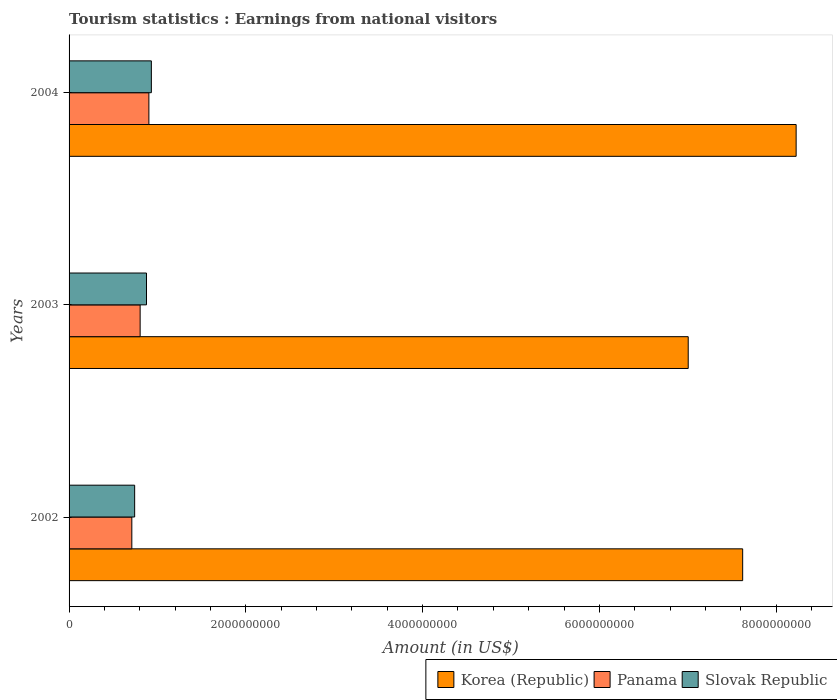How many different coloured bars are there?
Ensure brevity in your answer.  3. Are the number of bars per tick equal to the number of legend labels?
Give a very brief answer. Yes. How many bars are there on the 3rd tick from the top?
Your answer should be compact. 3. How many bars are there on the 2nd tick from the bottom?
Your answer should be compact. 3. In how many cases, is the number of bars for a given year not equal to the number of legend labels?
Your answer should be compact. 0. What is the earnings from national visitors in Slovak Republic in 2003?
Give a very brief answer. 8.76e+08. Across all years, what is the maximum earnings from national visitors in Panama?
Offer a very short reply. 9.03e+08. Across all years, what is the minimum earnings from national visitors in Panama?
Provide a succinct answer. 7.10e+08. In which year was the earnings from national visitors in Slovak Republic maximum?
Ensure brevity in your answer.  2004. In which year was the earnings from national visitors in Slovak Republic minimum?
Offer a terse response. 2002. What is the total earnings from national visitors in Korea (Republic) in the graph?
Your response must be concise. 2.29e+1. What is the difference between the earnings from national visitors in Korea (Republic) in 2003 and that in 2004?
Make the answer very short. -1.22e+09. What is the difference between the earnings from national visitors in Slovak Republic in 2004 and the earnings from national visitors in Panama in 2002?
Keep it short and to the point. 2.21e+08. What is the average earnings from national visitors in Slovak Republic per year?
Your answer should be very brief. 8.50e+08. In the year 2002, what is the difference between the earnings from national visitors in Panama and earnings from national visitors in Slovak Republic?
Your answer should be compact. -3.20e+07. In how many years, is the earnings from national visitors in Panama greater than 7600000000 US$?
Keep it short and to the point. 0. What is the ratio of the earnings from national visitors in Korea (Republic) in 2003 to that in 2004?
Make the answer very short. 0.85. Is the difference between the earnings from national visitors in Panama in 2002 and 2003 greater than the difference between the earnings from national visitors in Slovak Republic in 2002 and 2003?
Provide a short and direct response. Yes. What is the difference between the highest and the second highest earnings from national visitors in Panama?
Provide a short and direct response. 9.90e+07. What is the difference between the highest and the lowest earnings from national visitors in Korea (Republic)?
Give a very brief answer. 1.22e+09. What does the 2nd bar from the bottom in 2004 represents?
Offer a very short reply. Panama. How many bars are there?
Your answer should be very brief. 9. Are all the bars in the graph horizontal?
Your response must be concise. Yes. How many years are there in the graph?
Make the answer very short. 3. What is the difference between two consecutive major ticks on the X-axis?
Your answer should be compact. 2.00e+09. Are the values on the major ticks of X-axis written in scientific E-notation?
Keep it short and to the point. No. Does the graph contain any zero values?
Provide a succinct answer. No. Does the graph contain grids?
Ensure brevity in your answer.  No. What is the title of the graph?
Provide a short and direct response. Tourism statistics : Earnings from national visitors. What is the Amount (in US$) in Korea (Republic) in 2002?
Keep it short and to the point. 7.62e+09. What is the Amount (in US$) in Panama in 2002?
Keep it short and to the point. 7.10e+08. What is the Amount (in US$) of Slovak Republic in 2002?
Your answer should be very brief. 7.42e+08. What is the Amount (in US$) of Korea (Republic) in 2003?
Offer a very short reply. 7.00e+09. What is the Amount (in US$) of Panama in 2003?
Make the answer very short. 8.04e+08. What is the Amount (in US$) in Slovak Republic in 2003?
Provide a short and direct response. 8.76e+08. What is the Amount (in US$) in Korea (Republic) in 2004?
Offer a very short reply. 8.23e+09. What is the Amount (in US$) of Panama in 2004?
Offer a terse response. 9.03e+08. What is the Amount (in US$) of Slovak Republic in 2004?
Your response must be concise. 9.31e+08. Across all years, what is the maximum Amount (in US$) in Korea (Republic)?
Ensure brevity in your answer.  8.23e+09. Across all years, what is the maximum Amount (in US$) in Panama?
Make the answer very short. 9.03e+08. Across all years, what is the maximum Amount (in US$) in Slovak Republic?
Your answer should be compact. 9.31e+08. Across all years, what is the minimum Amount (in US$) of Korea (Republic)?
Keep it short and to the point. 7.00e+09. Across all years, what is the minimum Amount (in US$) of Panama?
Ensure brevity in your answer.  7.10e+08. Across all years, what is the minimum Amount (in US$) in Slovak Republic?
Offer a very short reply. 7.42e+08. What is the total Amount (in US$) in Korea (Republic) in the graph?
Provide a succinct answer. 2.29e+1. What is the total Amount (in US$) of Panama in the graph?
Your answer should be very brief. 2.42e+09. What is the total Amount (in US$) of Slovak Republic in the graph?
Make the answer very short. 2.55e+09. What is the difference between the Amount (in US$) in Korea (Republic) in 2002 and that in 2003?
Offer a terse response. 6.16e+08. What is the difference between the Amount (in US$) in Panama in 2002 and that in 2003?
Provide a succinct answer. -9.40e+07. What is the difference between the Amount (in US$) in Slovak Republic in 2002 and that in 2003?
Your response must be concise. -1.34e+08. What is the difference between the Amount (in US$) of Korea (Republic) in 2002 and that in 2004?
Make the answer very short. -6.05e+08. What is the difference between the Amount (in US$) in Panama in 2002 and that in 2004?
Provide a succinct answer. -1.93e+08. What is the difference between the Amount (in US$) in Slovak Republic in 2002 and that in 2004?
Offer a terse response. -1.89e+08. What is the difference between the Amount (in US$) in Korea (Republic) in 2003 and that in 2004?
Give a very brief answer. -1.22e+09. What is the difference between the Amount (in US$) of Panama in 2003 and that in 2004?
Offer a terse response. -9.90e+07. What is the difference between the Amount (in US$) in Slovak Republic in 2003 and that in 2004?
Your answer should be very brief. -5.50e+07. What is the difference between the Amount (in US$) of Korea (Republic) in 2002 and the Amount (in US$) of Panama in 2003?
Offer a terse response. 6.82e+09. What is the difference between the Amount (in US$) in Korea (Republic) in 2002 and the Amount (in US$) in Slovak Republic in 2003?
Ensure brevity in your answer.  6.74e+09. What is the difference between the Amount (in US$) in Panama in 2002 and the Amount (in US$) in Slovak Republic in 2003?
Provide a short and direct response. -1.66e+08. What is the difference between the Amount (in US$) of Korea (Republic) in 2002 and the Amount (in US$) of Panama in 2004?
Provide a short and direct response. 6.72e+09. What is the difference between the Amount (in US$) of Korea (Republic) in 2002 and the Amount (in US$) of Slovak Republic in 2004?
Provide a short and direct response. 6.69e+09. What is the difference between the Amount (in US$) of Panama in 2002 and the Amount (in US$) of Slovak Republic in 2004?
Keep it short and to the point. -2.21e+08. What is the difference between the Amount (in US$) of Korea (Republic) in 2003 and the Amount (in US$) of Panama in 2004?
Ensure brevity in your answer.  6.10e+09. What is the difference between the Amount (in US$) of Korea (Republic) in 2003 and the Amount (in US$) of Slovak Republic in 2004?
Keep it short and to the point. 6.07e+09. What is the difference between the Amount (in US$) in Panama in 2003 and the Amount (in US$) in Slovak Republic in 2004?
Your response must be concise. -1.27e+08. What is the average Amount (in US$) of Korea (Republic) per year?
Your answer should be very brief. 7.62e+09. What is the average Amount (in US$) of Panama per year?
Give a very brief answer. 8.06e+08. What is the average Amount (in US$) of Slovak Republic per year?
Ensure brevity in your answer.  8.50e+08. In the year 2002, what is the difference between the Amount (in US$) of Korea (Republic) and Amount (in US$) of Panama?
Make the answer very short. 6.91e+09. In the year 2002, what is the difference between the Amount (in US$) of Korea (Republic) and Amount (in US$) of Slovak Republic?
Give a very brief answer. 6.88e+09. In the year 2002, what is the difference between the Amount (in US$) of Panama and Amount (in US$) of Slovak Republic?
Your answer should be very brief. -3.20e+07. In the year 2003, what is the difference between the Amount (in US$) of Korea (Republic) and Amount (in US$) of Panama?
Ensure brevity in your answer.  6.20e+09. In the year 2003, what is the difference between the Amount (in US$) in Korea (Republic) and Amount (in US$) in Slovak Republic?
Ensure brevity in your answer.  6.13e+09. In the year 2003, what is the difference between the Amount (in US$) of Panama and Amount (in US$) of Slovak Republic?
Make the answer very short. -7.20e+07. In the year 2004, what is the difference between the Amount (in US$) of Korea (Republic) and Amount (in US$) of Panama?
Ensure brevity in your answer.  7.32e+09. In the year 2004, what is the difference between the Amount (in US$) of Korea (Republic) and Amount (in US$) of Slovak Republic?
Your response must be concise. 7.30e+09. In the year 2004, what is the difference between the Amount (in US$) in Panama and Amount (in US$) in Slovak Republic?
Ensure brevity in your answer.  -2.80e+07. What is the ratio of the Amount (in US$) in Korea (Republic) in 2002 to that in 2003?
Your answer should be compact. 1.09. What is the ratio of the Amount (in US$) in Panama in 2002 to that in 2003?
Offer a terse response. 0.88. What is the ratio of the Amount (in US$) in Slovak Republic in 2002 to that in 2003?
Offer a very short reply. 0.85. What is the ratio of the Amount (in US$) in Korea (Republic) in 2002 to that in 2004?
Provide a short and direct response. 0.93. What is the ratio of the Amount (in US$) of Panama in 2002 to that in 2004?
Offer a very short reply. 0.79. What is the ratio of the Amount (in US$) in Slovak Republic in 2002 to that in 2004?
Your answer should be very brief. 0.8. What is the ratio of the Amount (in US$) of Korea (Republic) in 2003 to that in 2004?
Offer a terse response. 0.85. What is the ratio of the Amount (in US$) of Panama in 2003 to that in 2004?
Your answer should be very brief. 0.89. What is the ratio of the Amount (in US$) of Slovak Republic in 2003 to that in 2004?
Provide a short and direct response. 0.94. What is the difference between the highest and the second highest Amount (in US$) in Korea (Republic)?
Offer a terse response. 6.05e+08. What is the difference between the highest and the second highest Amount (in US$) of Panama?
Provide a succinct answer. 9.90e+07. What is the difference between the highest and the second highest Amount (in US$) of Slovak Republic?
Keep it short and to the point. 5.50e+07. What is the difference between the highest and the lowest Amount (in US$) in Korea (Republic)?
Provide a succinct answer. 1.22e+09. What is the difference between the highest and the lowest Amount (in US$) in Panama?
Offer a terse response. 1.93e+08. What is the difference between the highest and the lowest Amount (in US$) in Slovak Republic?
Your response must be concise. 1.89e+08. 